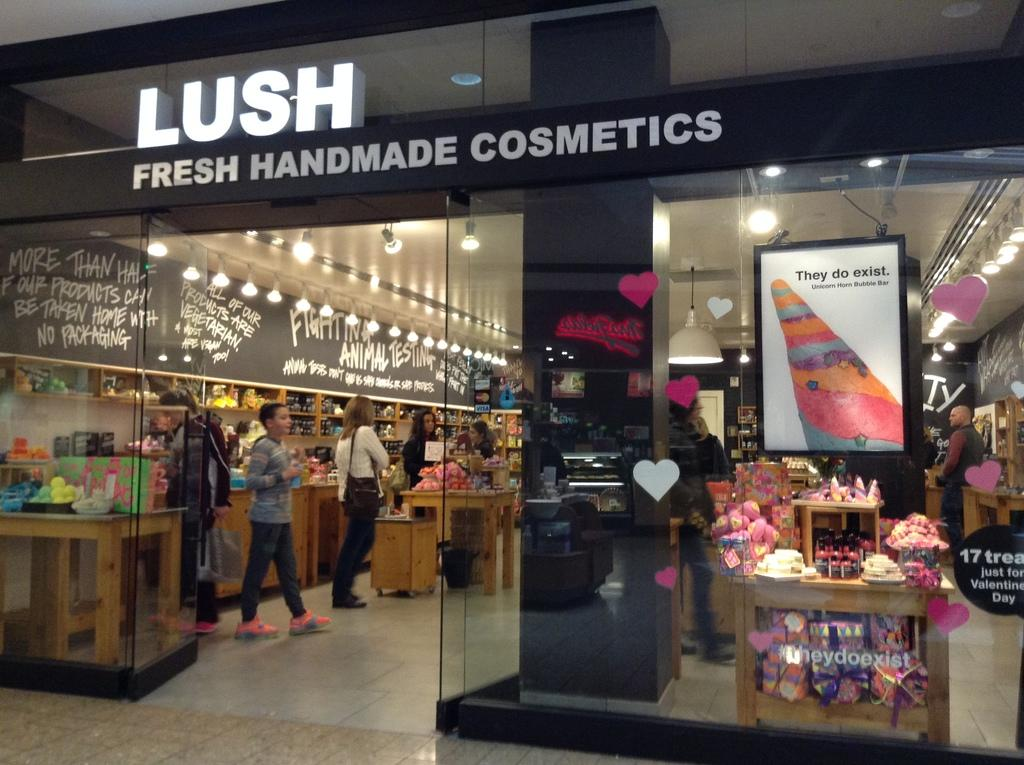<image>
Offer a succinct explanation of the picture presented. A woman walking in the LUSH Fresh Handmade Cosmetics store. 